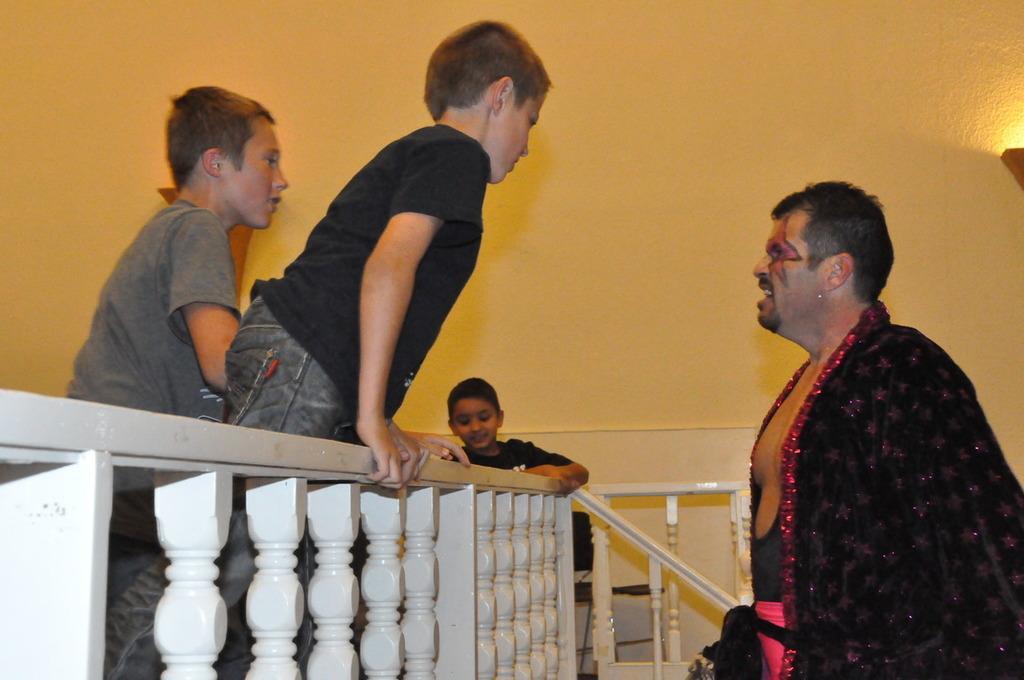In one or two sentences, can you explain what this image depicts? On the right side, there is a person in black color shirt standing in front of a fencing near three children. In the background, there is a yellow color wall and a light. 